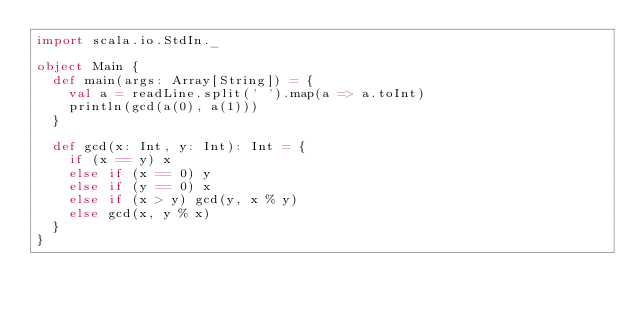Convert code to text. <code><loc_0><loc_0><loc_500><loc_500><_Scala_>import scala.io.StdIn._

object Main {
  def main(args: Array[String]) = {
    val a = readLine.split(' ').map(a => a.toInt)
    println(gcd(a(0), a(1)))
  }

  def gcd(x: Int, y: Int): Int = {
    if (x == y) x
    else if (x == 0) y
    else if (y == 0) x
    else if (x > y) gcd(y, x % y)
    else gcd(x, y % x)
  }
}</code> 